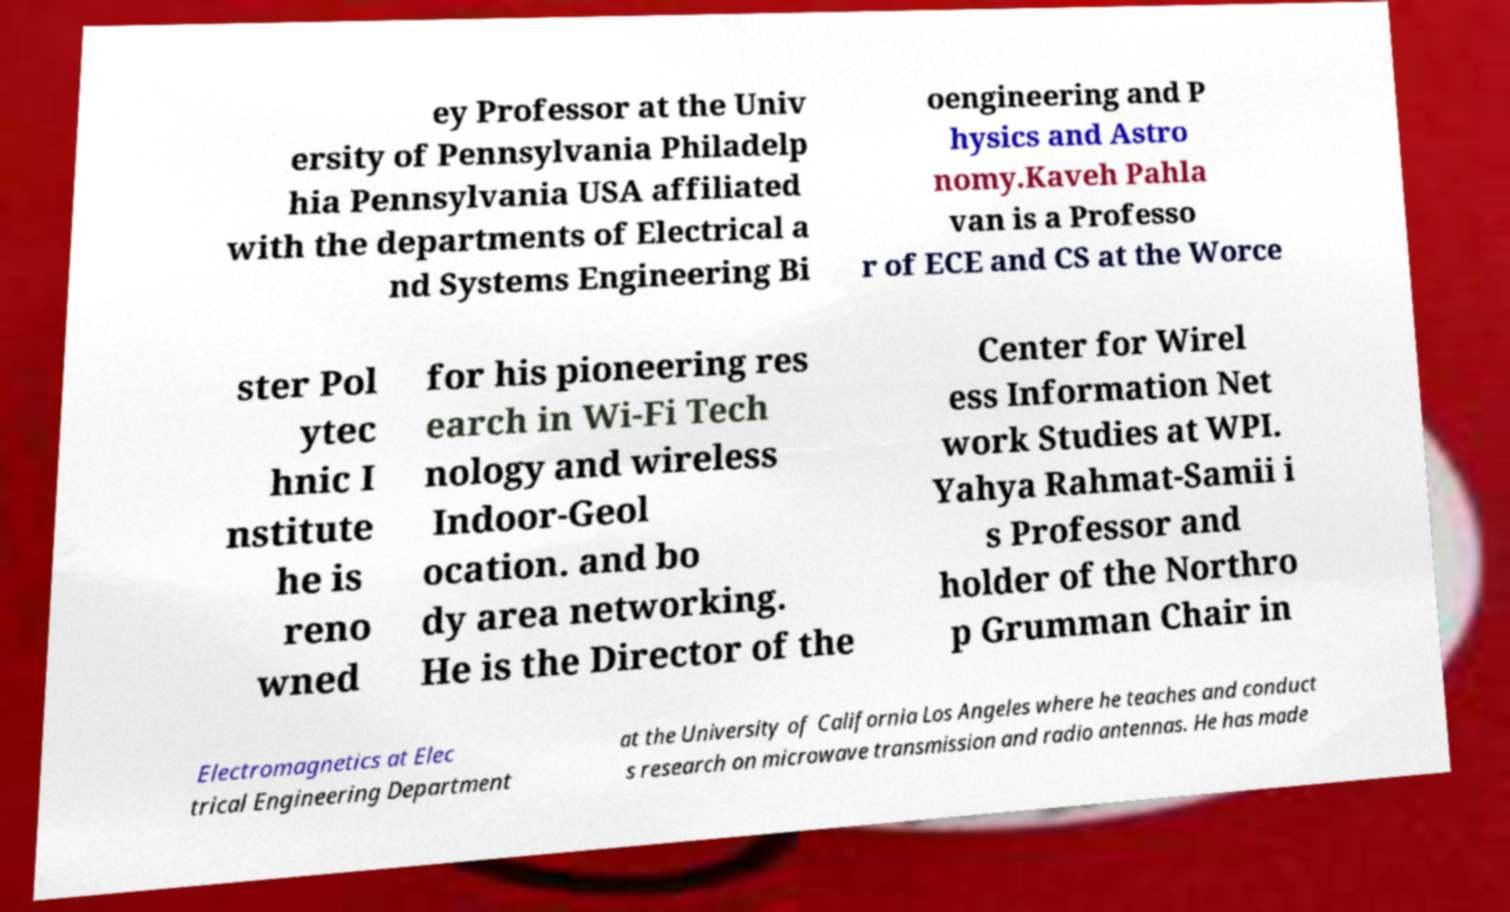What messages or text are displayed in this image? I need them in a readable, typed format. ey Professor at the Univ ersity of Pennsylvania Philadelp hia Pennsylvania USA affiliated with the departments of Electrical a nd Systems Engineering Bi oengineering and P hysics and Astro nomy.Kaveh Pahla van is a Professo r of ECE and CS at the Worce ster Pol ytec hnic I nstitute he is reno wned for his pioneering res earch in Wi-Fi Tech nology and wireless Indoor-Geol ocation. and bo dy area networking. He is the Director of the Center for Wirel ess Information Net work Studies at WPI. Yahya Rahmat-Samii i s Professor and holder of the Northro p Grumman Chair in Electromagnetics at Elec trical Engineering Department at the University of California Los Angeles where he teaches and conduct s research on microwave transmission and radio antennas. He has made 